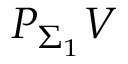<formula> <loc_0><loc_0><loc_500><loc_500>P _ { \Sigma _ { 1 } } V</formula> 